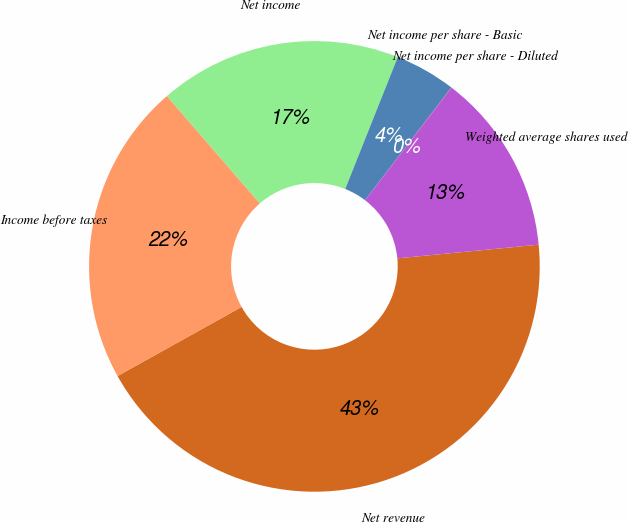Convert chart to OTSL. <chart><loc_0><loc_0><loc_500><loc_500><pie_chart><fcel>Net revenue<fcel>Income before taxes<fcel>Net income<fcel>Net income per share - Basic<fcel>Net income per share - Diluted<fcel>Weighted average shares used<nl><fcel>43.45%<fcel>21.73%<fcel>17.39%<fcel>4.36%<fcel>0.02%<fcel>13.05%<nl></chart> 